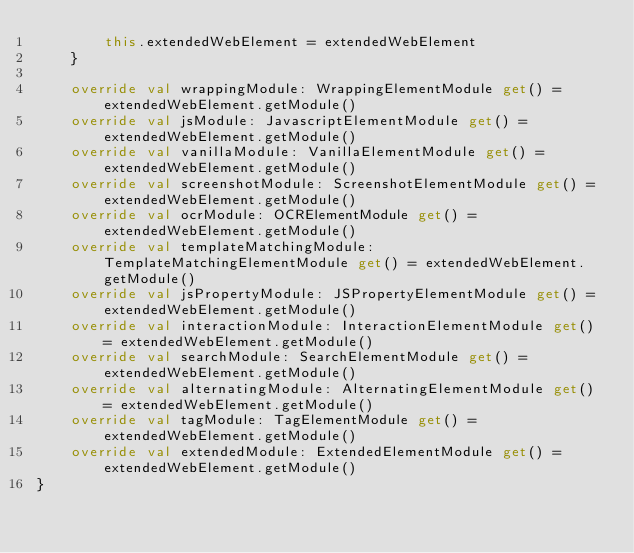<code> <loc_0><loc_0><loc_500><loc_500><_Kotlin_>        this.extendedWebElement = extendedWebElement
    }

    override val wrappingModule: WrappingElementModule get() = extendedWebElement.getModule()
    override val jsModule: JavascriptElementModule get() = extendedWebElement.getModule()
    override val vanillaModule: VanillaElementModule get() = extendedWebElement.getModule()
    override val screenshotModule: ScreenshotElementModule get() = extendedWebElement.getModule()
    override val ocrModule: OCRElementModule get() = extendedWebElement.getModule()
    override val templateMatchingModule: TemplateMatchingElementModule get() = extendedWebElement.getModule()
    override val jsPropertyModule: JSPropertyElementModule get() = extendedWebElement.getModule()
    override val interactionModule: InteractionElementModule get() = extendedWebElement.getModule()
    override val searchModule: SearchElementModule get() = extendedWebElement.getModule()
    override val alternatingModule: AlternatingElementModule get() = extendedWebElement.getModule()
    override val tagModule: TagElementModule get() = extendedWebElement.getModule()
    override val extendedModule: ExtendedElementModule get() = extendedWebElement.getModule()
}</code> 